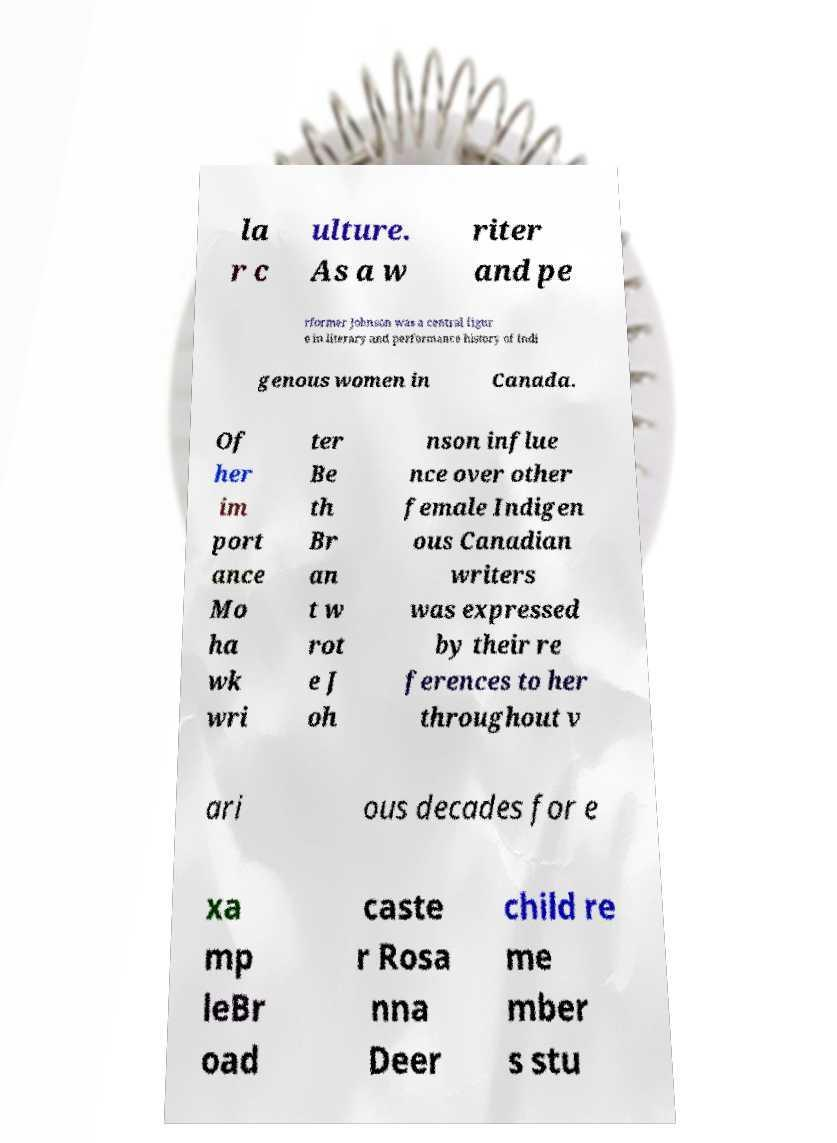Please identify and transcribe the text found in this image. la r c ulture. As a w riter and pe rformer Johnson was a central figur e in literary and performance history of Indi genous women in Canada. Of her im port ance Mo ha wk wri ter Be th Br an t w rot e J oh nson influe nce over other female Indigen ous Canadian writers was expressed by their re ferences to her throughout v ari ous decades for e xa mp leBr oad caste r Rosa nna Deer child re me mber s stu 